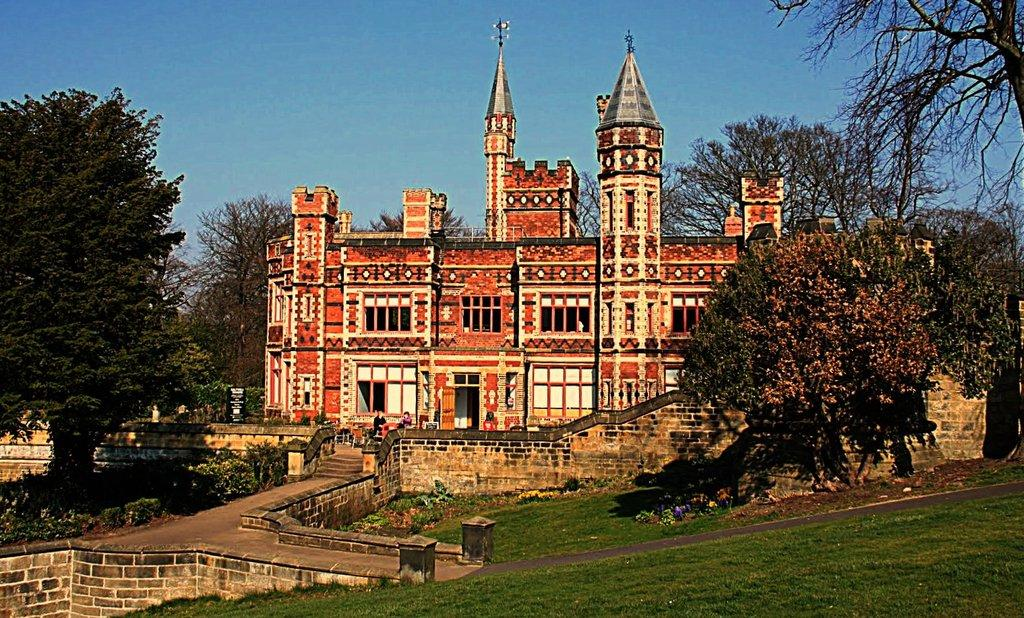What is the main structure in the image? There is a building in the image. Are there any people near the building? Yes, there are two people in front of the building. What type of natural elements can be seen around the building? There are trees around the building. What additional feature can be seen in the image? There is a display board in the image. Where is the dock located in the image? There is no dock present in the image. What type of cattle can be seen grazing near the building? There are no cattle present in the image. 